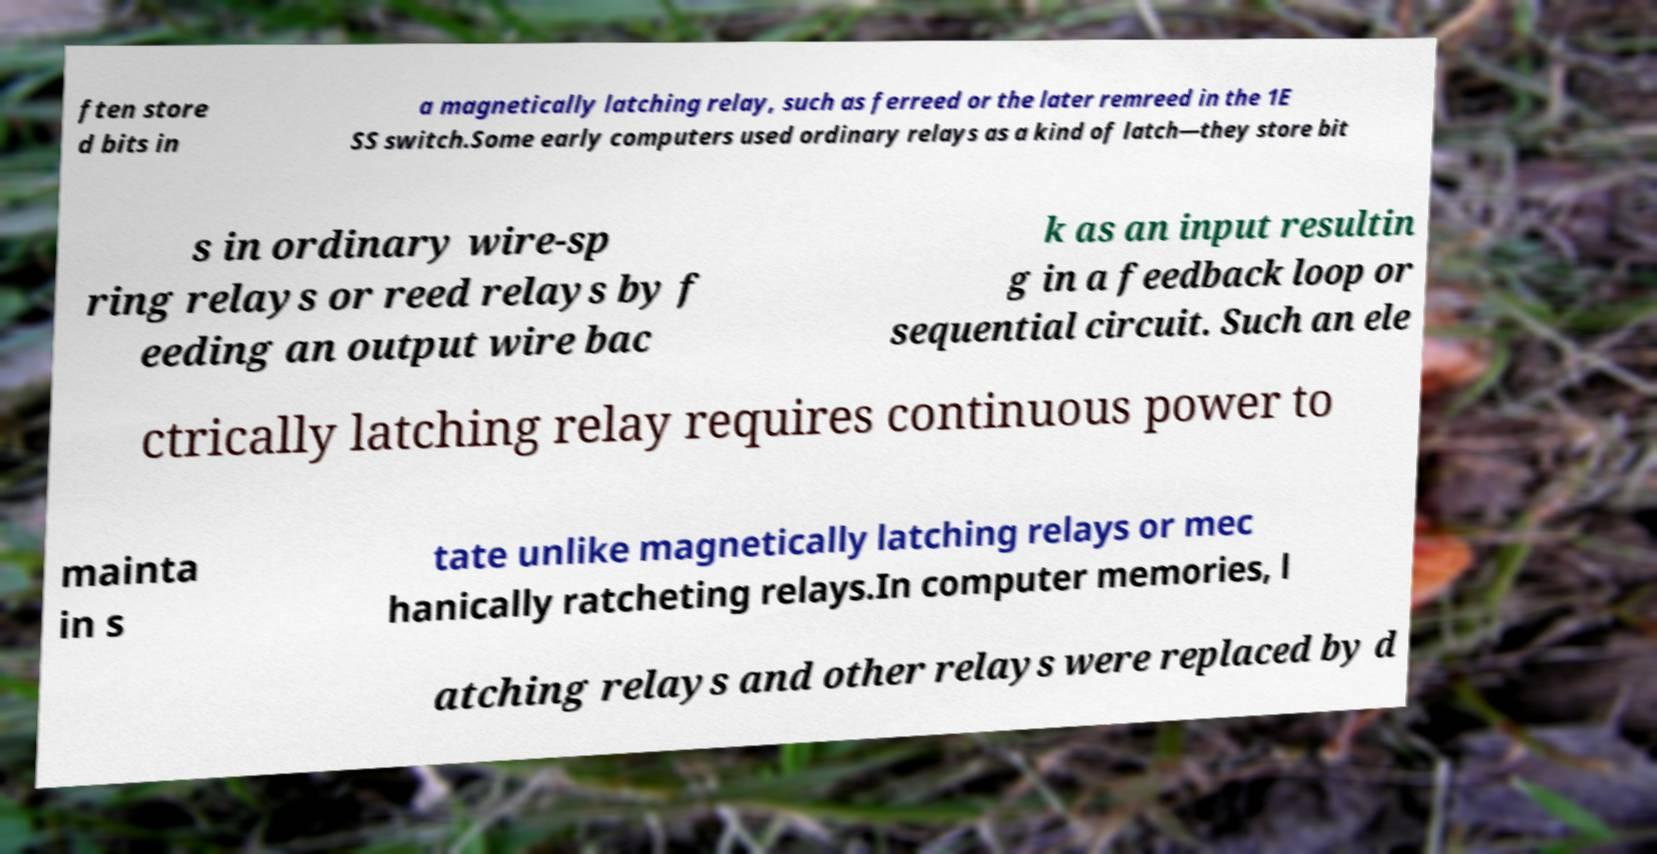For documentation purposes, I need the text within this image transcribed. Could you provide that? ften store d bits in a magnetically latching relay, such as ferreed or the later remreed in the 1E SS switch.Some early computers used ordinary relays as a kind of latch—they store bit s in ordinary wire-sp ring relays or reed relays by f eeding an output wire bac k as an input resultin g in a feedback loop or sequential circuit. Such an ele ctrically latching relay requires continuous power to mainta in s tate unlike magnetically latching relays or mec hanically ratcheting relays.In computer memories, l atching relays and other relays were replaced by d 